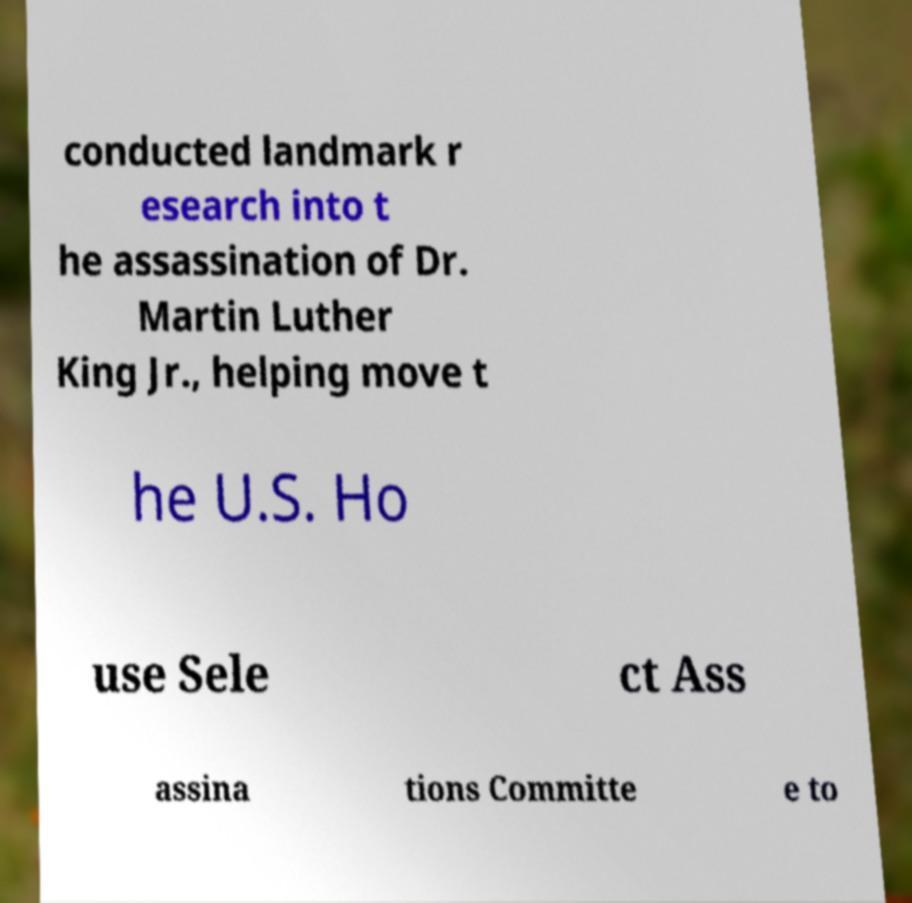For documentation purposes, I need the text within this image transcribed. Could you provide that? conducted landmark r esearch into t he assassination of Dr. Martin Luther King Jr., helping move t he U.S. Ho use Sele ct Ass assina tions Committe e to 